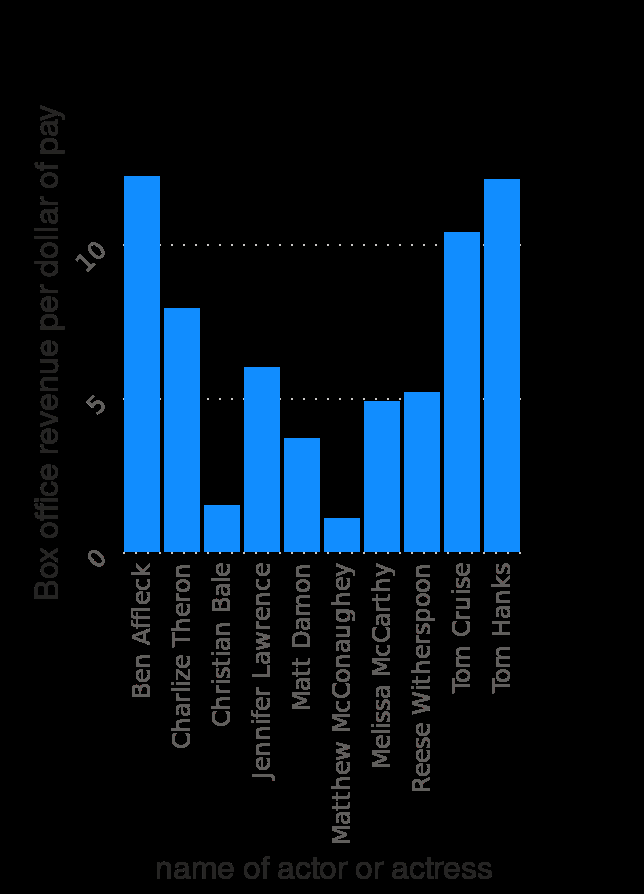<image>
How are the actors arranged in the given figure?  The actors are arranged along the x axis in alphabetical order. Describe the following image in detail Here a bar diagram is titled Most overpaid actors in Hollywood in 2018 , ranked by box office revenue per dollar of their pay (in U.S. dollars). The x-axis shows name of actor or actress along categorical scale with Ben Affleck on one end and  at the other while the y-axis shows Box office revenue per dollar of pay using linear scale from 0 to 10. What is the basis for arranging the actors in the figure?  The actors are arranged in alphabetical order along the x axis. 